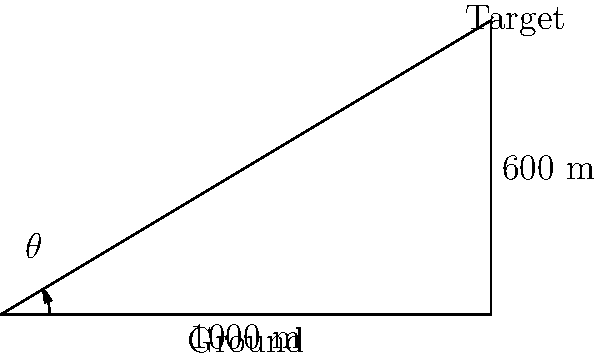A long-range shooter is practicing their marksmanship skills. The target is positioned 1000 meters away horizontally and 600 meters above the shooter's position. What is the angle of elevation ($\theta$) the shooter needs to aim at for optimal accuracy? Round your answer to the nearest degree. To solve this problem, we'll use trigonometry, specifically the tangent function.

1) First, let's identify the components of the right triangle:
   - The adjacent side is the horizontal distance: 1000 meters
   - The opposite side is the vertical distance: 600 meters
   - The angle we're looking for is $\theta$

2) The tangent of an angle in a right triangle is defined as the ratio of the opposite side to the adjacent side:

   $\tan(\theta) = \frac{\text{opposite}}{\text{adjacent}} = \frac{600}{1000} = 0.6$

3) To find $\theta$, we need to use the inverse tangent (arctan or $\tan^{-1}$) function:

   $\theta = \tan^{-1}(0.6)$

4) Using a calculator or trigonometric tables:

   $\theta \approx 30.9638^\circ$

5) Rounding to the nearest degree:

   $\theta \approx 31^\circ$

Therefore, the shooter should aim at an angle of elevation of approximately 31 degrees for optimal accuracy.
Answer: $31^\circ$ 